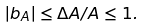<formula> <loc_0><loc_0><loc_500><loc_500>| b _ { A } | \leq \Delta A / A \leq 1 .</formula> 